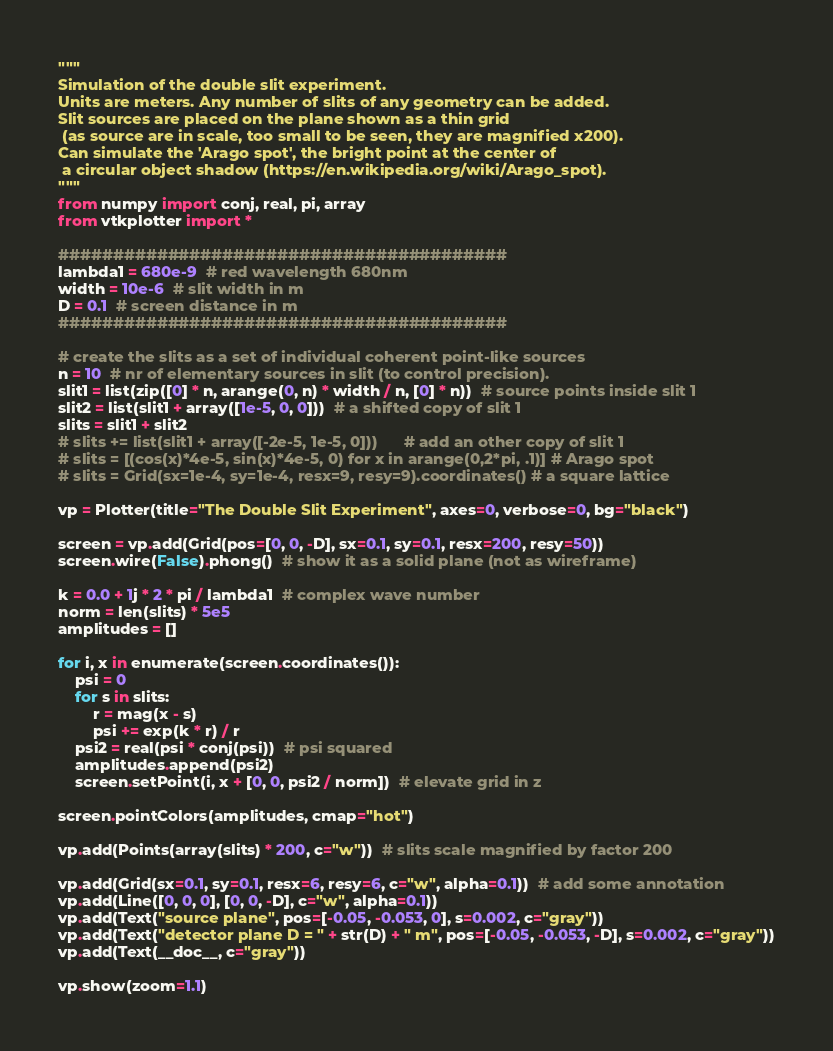Convert code to text. <code><loc_0><loc_0><loc_500><loc_500><_Python_>"""
Simulation of the double slit experiment.
Units are meters. Any number of slits of any geometry can be added.
Slit sources are placed on the plane shown as a thin grid
 (as source are in scale, too small to be seen, they are magnified x200).
Can simulate the 'Arago spot', the bright point at the center of
 a circular object shadow (https://en.wikipedia.org/wiki/Arago_spot).
"""
from numpy import conj, real, pi, array
from vtkplotter import *

#########################################
lambda1 = 680e-9  # red wavelength 680nm
width = 10e-6  # slit width in m
D = 0.1  # screen distance in m
#########################################

# create the slits as a set of individual coherent point-like sources
n = 10  # nr of elementary sources in slit (to control precision).
slit1 = list(zip([0] * n, arange(0, n) * width / n, [0] * n))  # source points inside slit 1
slit2 = list(slit1 + array([1e-5, 0, 0]))  # a shifted copy of slit 1
slits = slit1 + slit2
# slits += list(slit1 + array([-2e-5, 1e-5, 0]))      # add an other copy of slit 1
# slits = [(cos(x)*4e-5, sin(x)*4e-5, 0) for x in arange(0,2*pi, .1)] # Arago spot
# slits = Grid(sx=1e-4, sy=1e-4, resx=9, resy=9).coordinates() # a square lattice

vp = Plotter(title="The Double Slit Experiment", axes=0, verbose=0, bg="black")

screen = vp.add(Grid(pos=[0, 0, -D], sx=0.1, sy=0.1, resx=200, resy=50))
screen.wire(False).phong()  # show it as a solid plane (not as wireframe)

k = 0.0 + 1j * 2 * pi / lambda1  # complex wave number
norm = len(slits) * 5e5
amplitudes = []

for i, x in enumerate(screen.coordinates()):
    psi = 0
    for s in slits:
        r = mag(x - s)
        psi += exp(k * r) / r
    psi2 = real(psi * conj(psi))  # psi squared
    amplitudes.append(psi2)
    screen.setPoint(i, x + [0, 0, psi2 / norm])  # elevate grid in z

screen.pointColors(amplitudes, cmap="hot")

vp.add(Points(array(slits) * 200, c="w"))  # slits scale magnified by factor 200

vp.add(Grid(sx=0.1, sy=0.1, resx=6, resy=6, c="w", alpha=0.1))  # add some annotation
vp.add(Line([0, 0, 0], [0, 0, -D], c="w", alpha=0.1))
vp.add(Text("source plane", pos=[-0.05, -0.053, 0], s=0.002, c="gray"))
vp.add(Text("detector plane D = " + str(D) + " m", pos=[-0.05, -0.053, -D], s=0.002, c="gray"))
vp.add(Text(__doc__, c="gray"))

vp.show(zoom=1.1)
</code> 